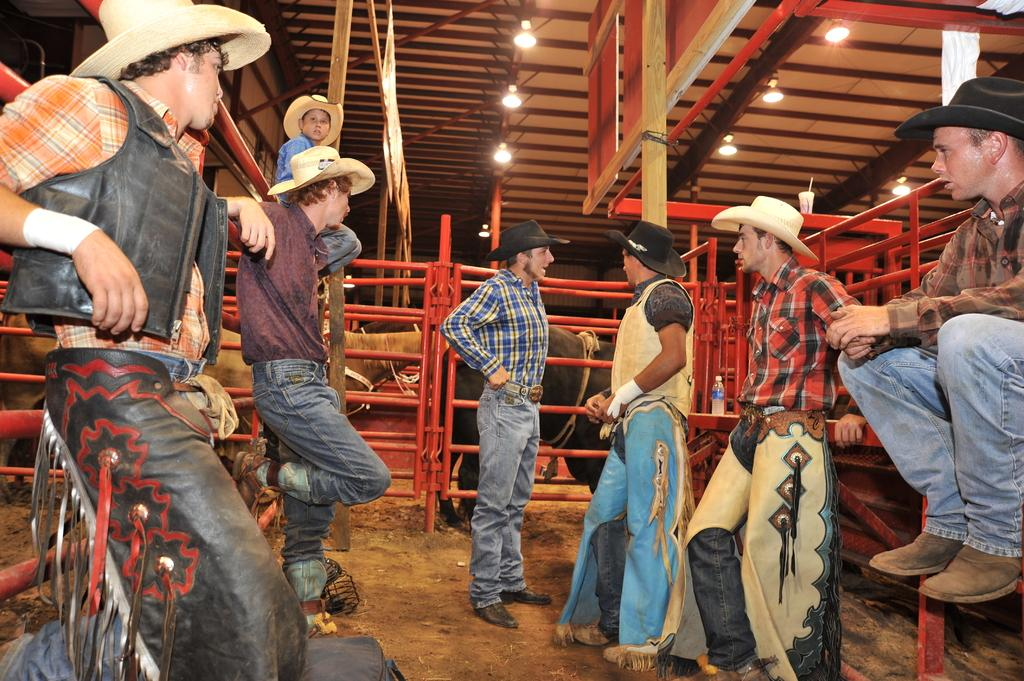What is happening in the image? There is a group of people standing in the image. What can be seen in the background of the image? There are animals with brown and black colors in the background of the image. What type of structure is visible in the image? There is railing visible in the image. What might be used for illumination in the image? There are lights present in the image. What type of mint can be seen growing near the people in the image? There is no mint present in the image. Can you describe the bee that is buzzing around the lights in the image? There are no bees present in the image. 